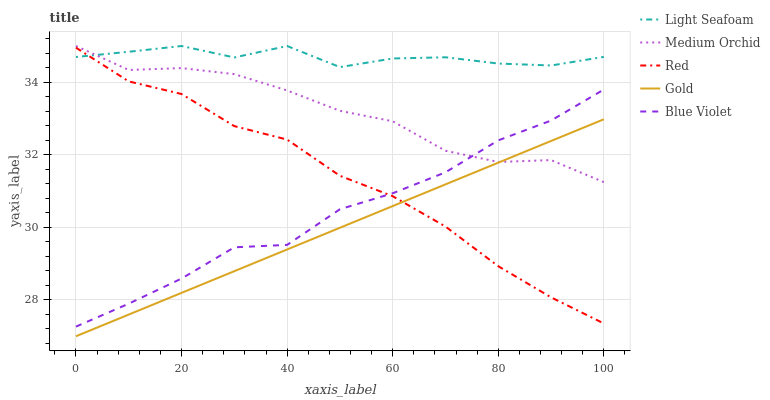Does Gold have the minimum area under the curve?
Answer yes or no. Yes. Does Light Seafoam have the maximum area under the curve?
Answer yes or no. Yes. Does Medium Orchid have the minimum area under the curve?
Answer yes or no. No. Does Medium Orchid have the maximum area under the curve?
Answer yes or no. No. Is Gold the smoothest?
Answer yes or no. Yes. Is Light Seafoam the roughest?
Answer yes or no. Yes. Is Medium Orchid the smoothest?
Answer yes or no. No. Is Medium Orchid the roughest?
Answer yes or no. No. Does Gold have the lowest value?
Answer yes or no. Yes. Does Medium Orchid have the lowest value?
Answer yes or no. No. Does Light Seafoam have the highest value?
Answer yes or no. Yes. Does Gold have the highest value?
Answer yes or no. No. Is Gold less than Blue Violet?
Answer yes or no. Yes. Is Medium Orchid greater than Red?
Answer yes or no. Yes. Does Medium Orchid intersect Blue Violet?
Answer yes or no. Yes. Is Medium Orchid less than Blue Violet?
Answer yes or no. No. Is Medium Orchid greater than Blue Violet?
Answer yes or no. No. Does Gold intersect Blue Violet?
Answer yes or no. No. 